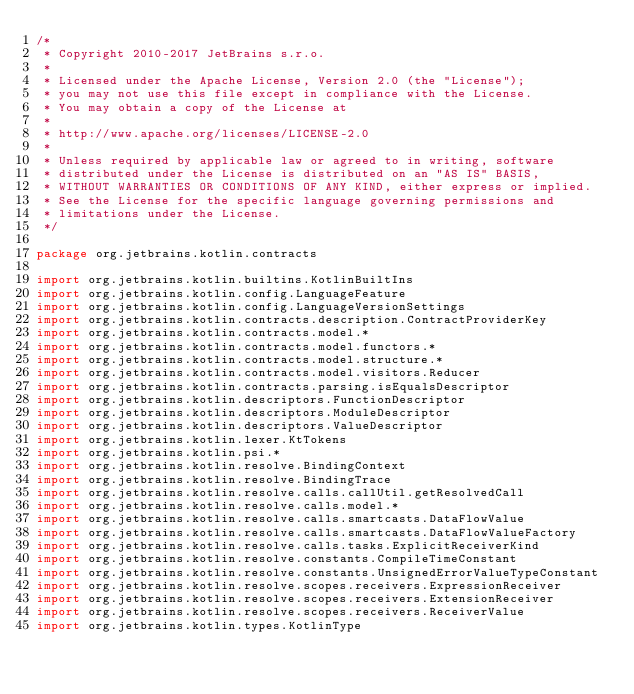Convert code to text. <code><loc_0><loc_0><loc_500><loc_500><_Kotlin_>/*
 * Copyright 2010-2017 JetBrains s.r.o.
 *
 * Licensed under the Apache License, Version 2.0 (the "License");
 * you may not use this file except in compliance with the License.
 * You may obtain a copy of the License at
 *
 * http://www.apache.org/licenses/LICENSE-2.0
 *
 * Unless required by applicable law or agreed to in writing, software
 * distributed under the License is distributed on an "AS IS" BASIS,
 * WITHOUT WARRANTIES OR CONDITIONS OF ANY KIND, either express or implied.
 * See the License for the specific language governing permissions and
 * limitations under the License.
 */

package org.jetbrains.kotlin.contracts

import org.jetbrains.kotlin.builtins.KotlinBuiltIns
import org.jetbrains.kotlin.config.LanguageFeature
import org.jetbrains.kotlin.config.LanguageVersionSettings
import org.jetbrains.kotlin.contracts.description.ContractProviderKey
import org.jetbrains.kotlin.contracts.model.*
import org.jetbrains.kotlin.contracts.model.functors.*
import org.jetbrains.kotlin.contracts.model.structure.*
import org.jetbrains.kotlin.contracts.model.visitors.Reducer
import org.jetbrains.kotlin.contracts.parsing.isEqualsDescriptor
import org.jetbrains.kotlin.descriptors.FunctionDescriptor
import org.jetbrains.kotlin.descriptors.ModuleDescriptor
import org.jetbrains.kotlin.descriptors.ValueDescriptor
import org.jetbrains.kotlin.lexer.KtTokens
import org.jetbrains.kotlin.psi.*
import org.jetbrains.kotlin.resolve.BindingContext
import org.jetbrains.kotlin.resolve.BindingTrace
import org.jetbrains.kotlin.resolve.calls.callUtil.getResolvedCall
import org.jetbrains.kotlin.resolve.calls.model.*
import org.jetbrains.kotlin.resolve.calls.smartcasts.DataFlowValue
import org.jetbrains.kotlin.resolve.calls.smartcasts.DataFlowValueFactory
import org.jetbrains.kotlin.resolve.calls.tasks.ExplicitReceiverKind
import org.jetbrains.kotlin.resolve.constants.CompileTimeConstant
import org.jetbrains.kotlin.resolve.constants.UnsignedErrorValueTypeConstant
import org.jetbrains.kotlin.resolve.scopes.receivers.ExpressionReceiver
import org.jetbrains.kotlin.resolve.scopes.receivers.ExtensionReceiver
import org.jetbrains.kotlin.resolve.scopes.receivers.ReceiverValue
import org.jetbrains.kotlin.types.KotlinType</code> 